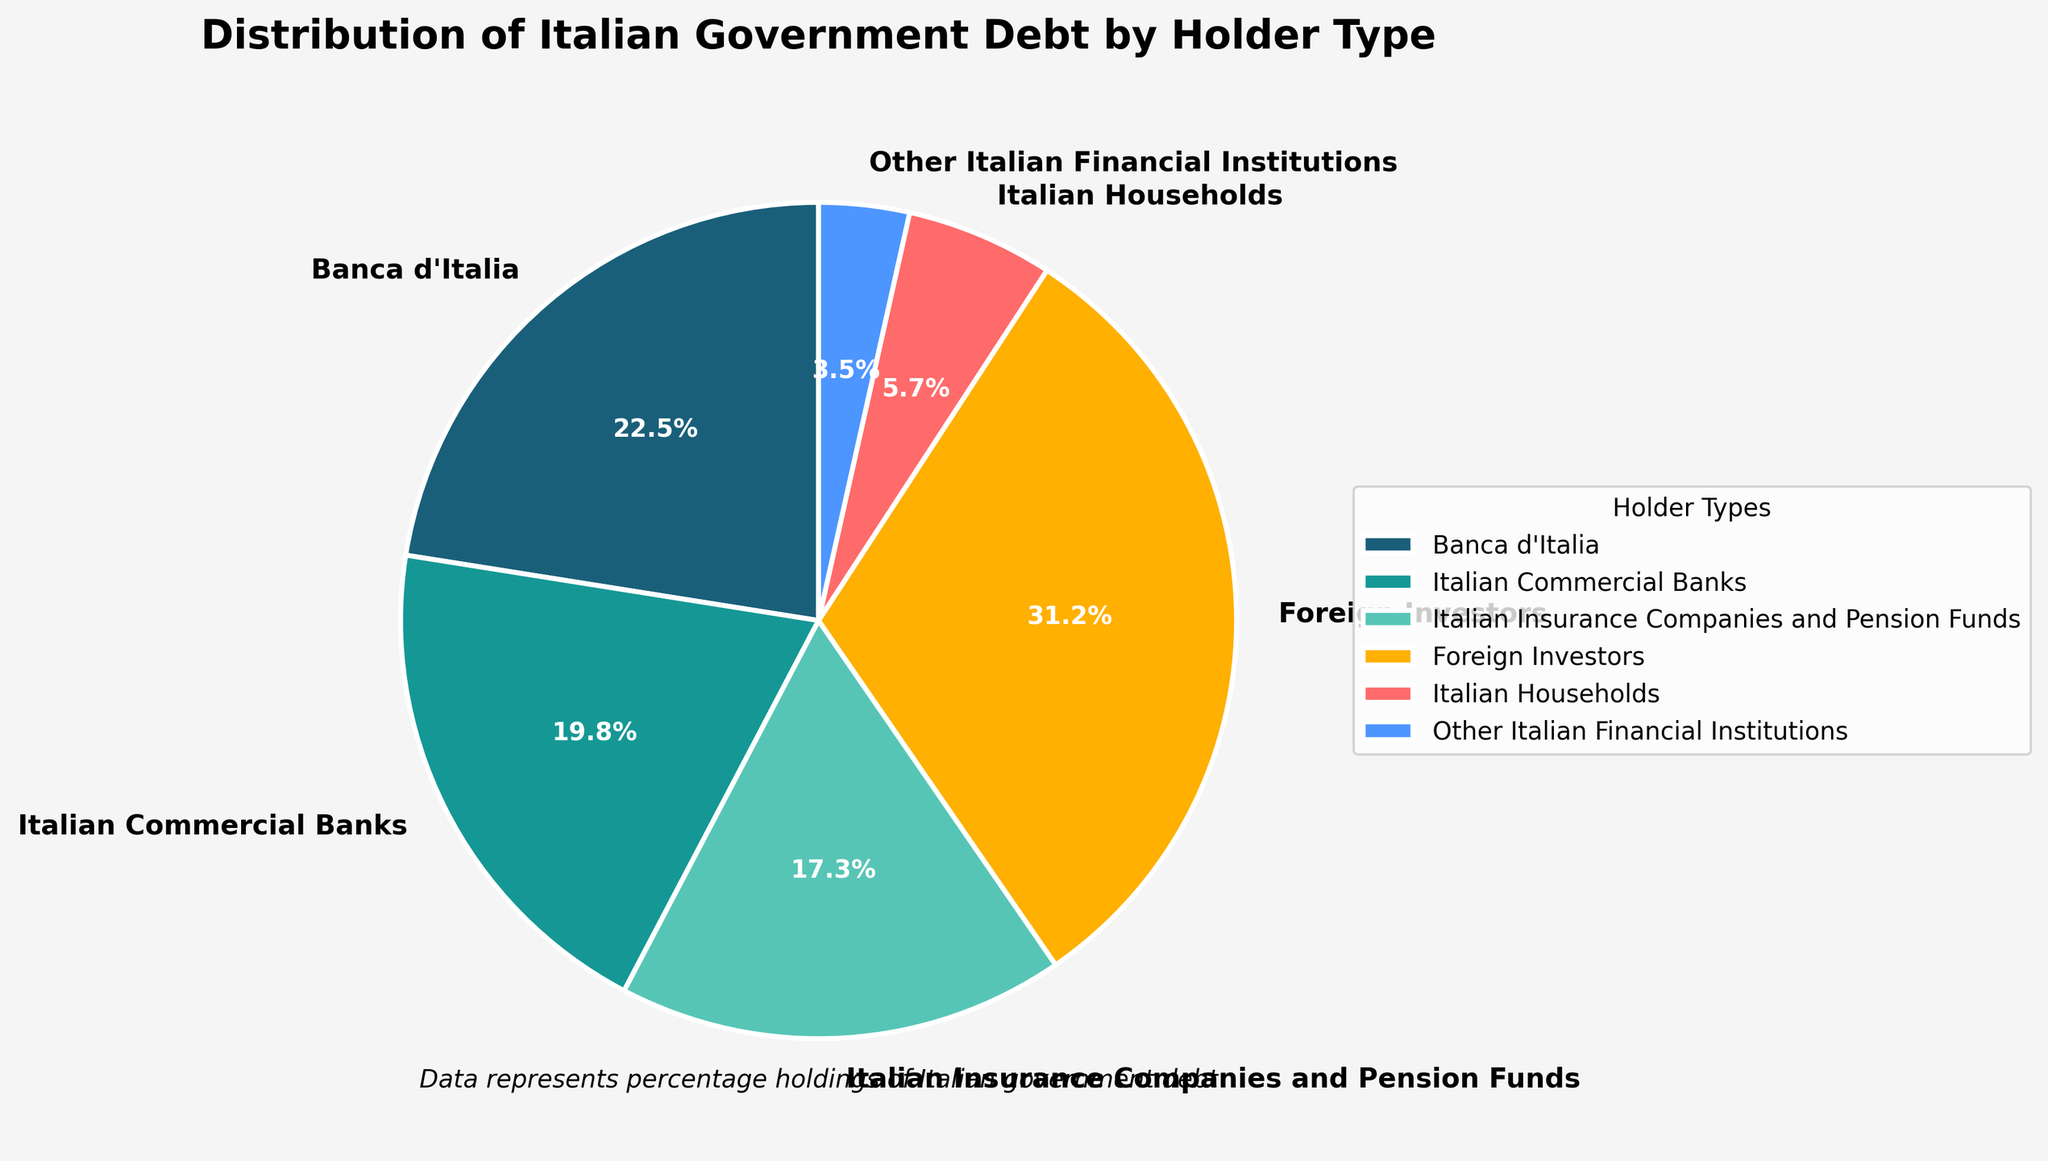What percentage of Italian government debt is held by domestic banks and insurance companies combined? First, identify the percentage held by Italian Commercial Banks (19.8%) and Italian Insurance Companies and Pension Funds (17.3%). Then sum these values: 19.8 + 17.3 = 37.1
Answer: 37.1% Which type of holder holds the largest share of the Italian government debt? Compare the percentages of each holder type. The largest percentage is held by Foreign Investors (31.2%)
Answer: Foreign Investors How much more Italian government debt does the central bank hold compared to Italian households? Identify the percentages held by Banca d'Italia (22.5%) and Italian Households (5.7%). Subtract the household percentage from the central bank percentage: 22.5 - 5.7 = 16.8
Answer: 16.8% Are Italian Financial Institutions holding more or less government debt than Italian Households? Compare the percentages of Other Italian Financial Institutions (3.5%) and Italian Households (5.7%). 3.5% is less than 5.7%
Answer: Less Which segment is represented by a yellow wedge in the pie chart? The color yellow corresponds to the Italian Households segment.
Answer: Italian Households What is the total percentage of debt held by foreign and domestic non-bank entities (insurance companies and households)? Add the percentages of Foreign Investors (31.2%), Italian Insurance Companies and Pension Funds (17.3%), and Italian Households (5.7%): 31.2 + 17.3 + 5.7 = 54.2
Answer: 54.2% Is the share of the debt held by foreign investors larger than the combined share of all Italian non-banks (excluding other financial institutions)? Compare Foreign Investors (31.2%) with the combined percentages of Italian Insurance Companies and Pension Funds (17.3%) and Italian Households (5.7%): 17.3 + 5.7 = 23. Combined share (23%) is less than Foreign Investors (31.2%)
Answer: Yes Which two categories combined hold the least share of the debt? Identify the two smallest percentages: Other Italian Financial Institutions (3.5%) and Italian Households (5.7%). Summing these gives 3.5 + 5.7 = 9.2%, the smallest combined share
Answer: Other Italian Financial Institutions and Italian Households By how many percentage points do foreign investors' holdings exceed those of Italian Commercial Banks? Subtract the percentage held by Italian Commercial Banks (19.8%) from that held by Foreign Investors (31.2%): 31.2 - 19.8 = 11.4
Answer: 11.4 